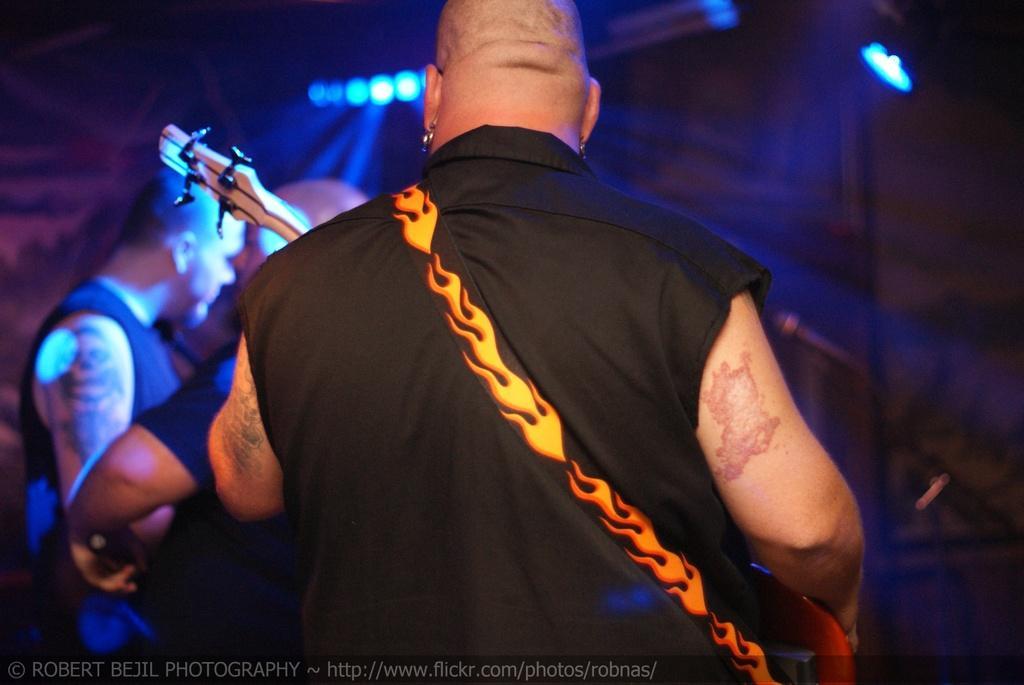Could you give a brief overview of what you see in this image? In this image there are few people in which one of them plays a musical instrument, there are lights to the roof, a microphone to a stand and some clouds in the sky. 